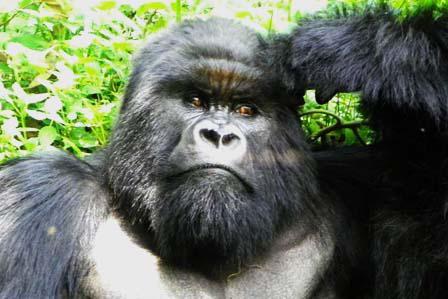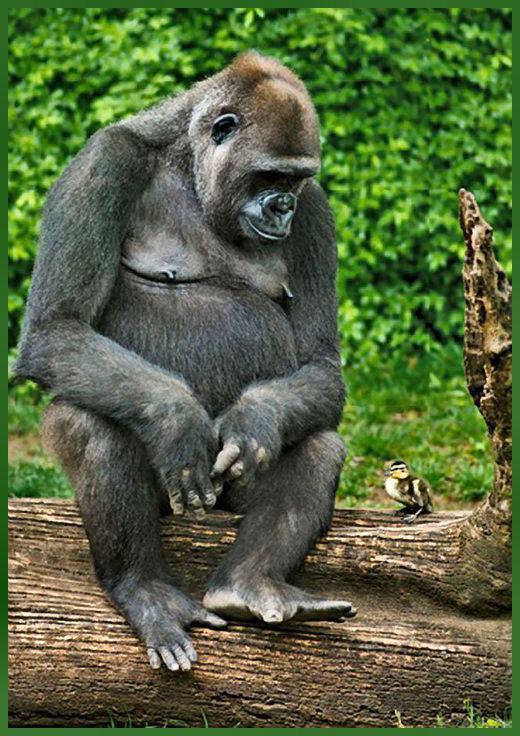The first image is the image on the left, the second image is the image on the right. Evaluate the accuracy of this statement regarding the images: "The ape on the right is eating something.". Is it true? Answer yes or no. No. The first image is the image on the left, the second image is the image on the right. For the images shown, is this caption "No image contains more than one gorilla, and each gorilla is gazing in a way that its eyes are visible." true? Answer yes or no. No. 